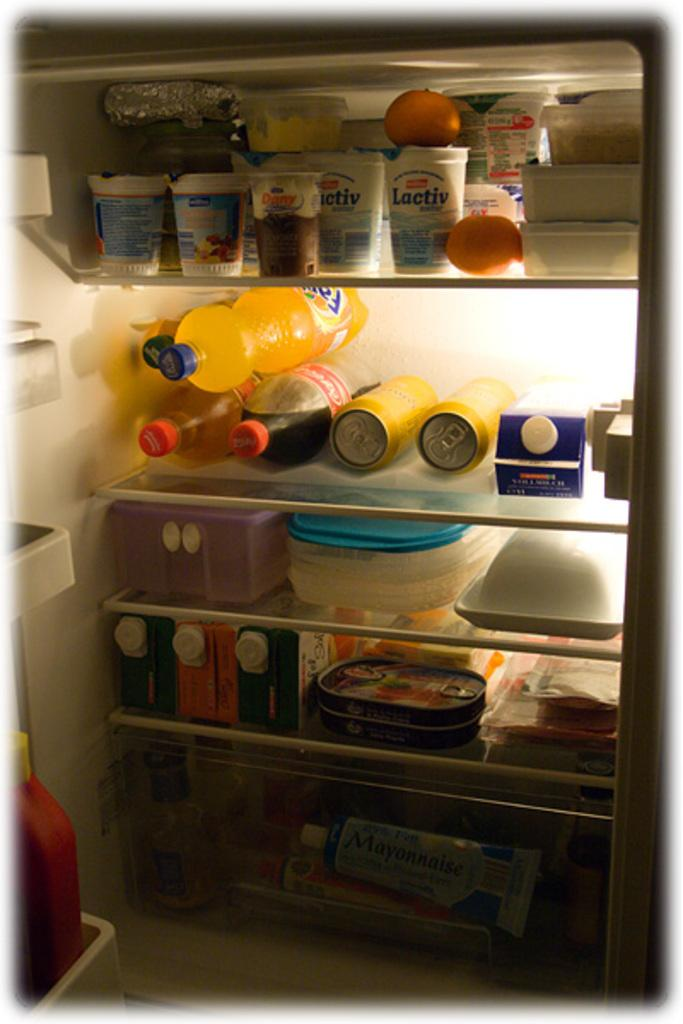Provide a one-sentence caption for the provided image. Proactiv and Dany yogurts sit on the top shelf of the fridge. 